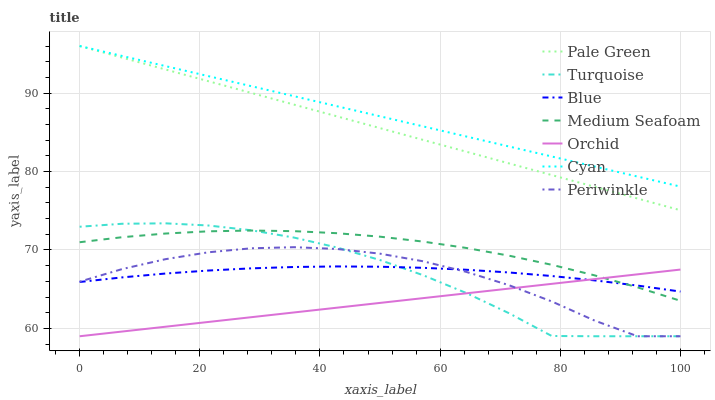Does Orchid have the minimum area under the curve?
Answer yes or no. Yes. Does Cyan have the maximum area under the curve?
Answer yes or no. Yes. Does Turquoise have the minimum area under the curve?
Answer yes or no. No. Does Turquoise have the maximum area under the curve?
Answer yes or no. No. Is Orchid the smoothest?
Answer yes or no. Yes. Is Periwinkle the roughest?
Answer yes or no. Yes. Is Turquoise the smoothest?
Answer yes or no. No. Is Turquoise the roughest?
Answer yes or no. No. Does Turquoise have the lowest value?
Answer yes or no. Yes. Does Pale Green have the lowest value?
Answer yes or no. No. Does Cyan have the highest value?
Answer yes or no. Yes. Does Turquoise have the highest value?
Answer yes or no. No. Is Periwinkle less than Medium Seafoam?
Answer yes or no. Yes. Is Cyan greater than Blue?
Answer yes or no. Yes. Does Blue intersect Turquoise?
Answer yes or no. Yes. Is Blue less than Turquoise?
Answer yes or no. No. Is Blue greater than Turquoise?
Answer yes or no. No. Does Periwinkle intersect Medium Seafoam?
Answer yes or no. No. 